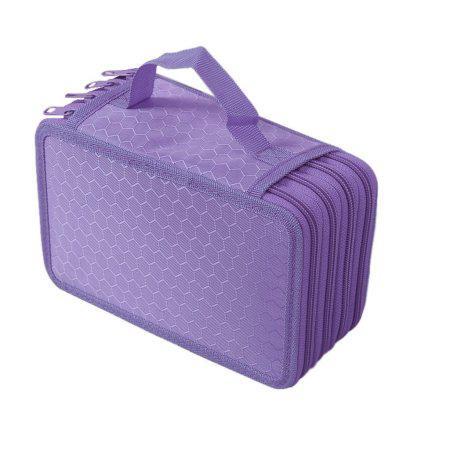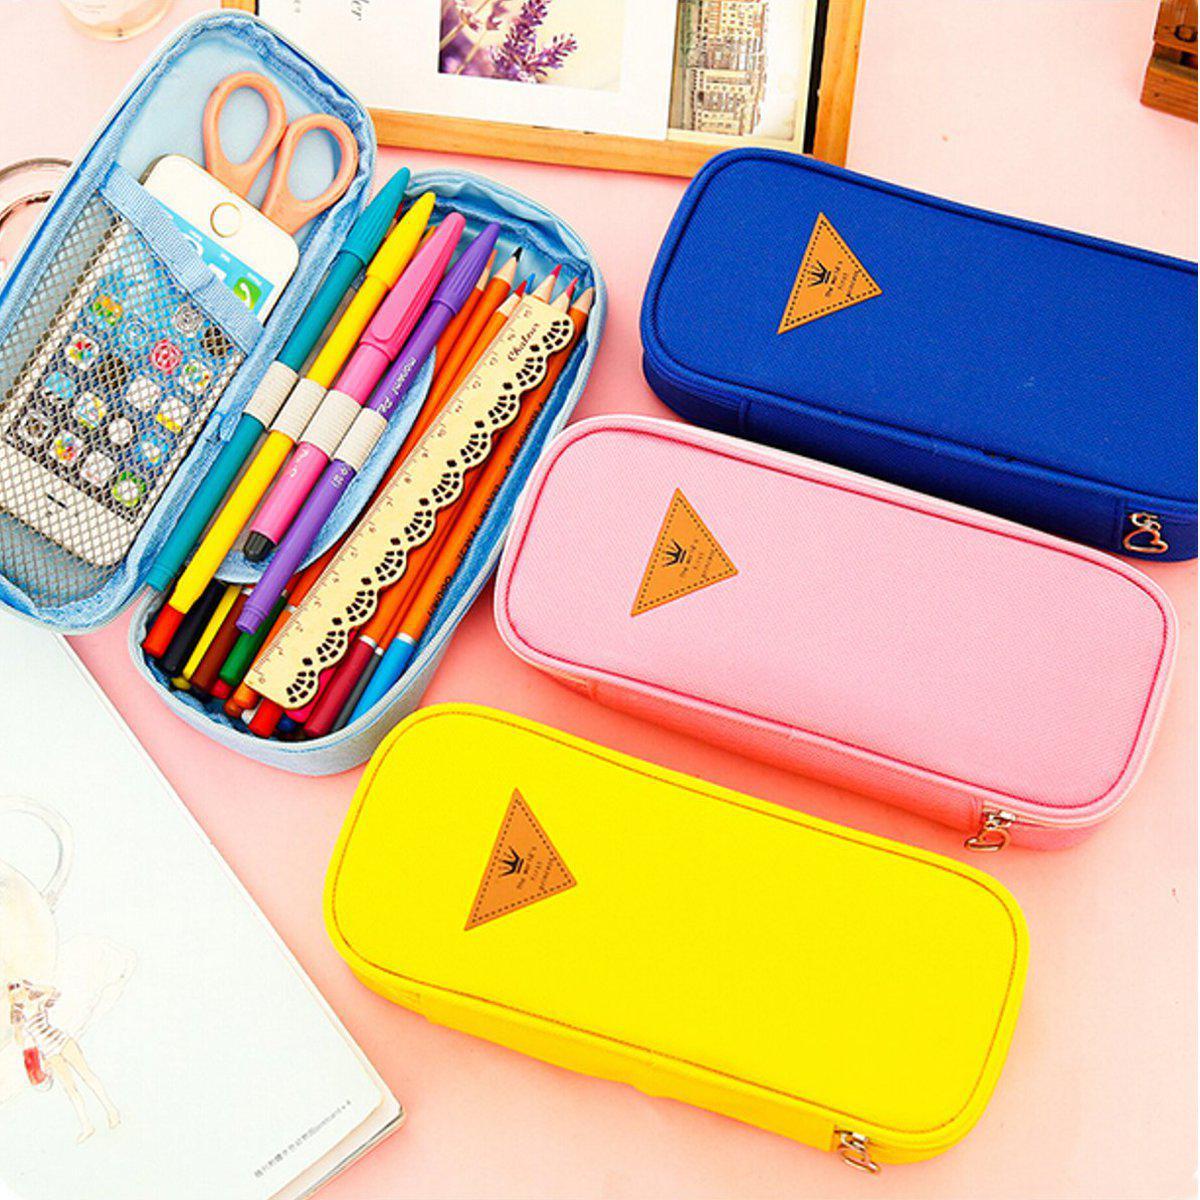The first image is the image on the left, the second image is the image on the right. For the images displayed, is the sentence "There is an image that has an open and a closed case" factually correct? Answer yes or no. Yes. The first image is the image on the left, the second image is the image on the right. Examine the images to the left and right. Is the description "At least one image contains a single pencil case." accurate? Answer yes or no. Yes. The first image is the image on the left, the second image is the image on the right. Examine the images to the left and right. Is the description "The left image shows exactly one case." accurate? Answer yes or no. Yes. 